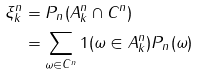Convert formula to latex. <formula><loc_0><loc_0><loc_500><loc_500>\xi _ { k } ^ { n } & = P _ { n } ( A _ { k } ^ { n } \cap C ^ { n } ) \\ & = \sum _ { \omega \in C ^ { n } } 1 ( \omega \in A _ { k } ^ { n } ) P _ { n } ( \omega )</formula> 